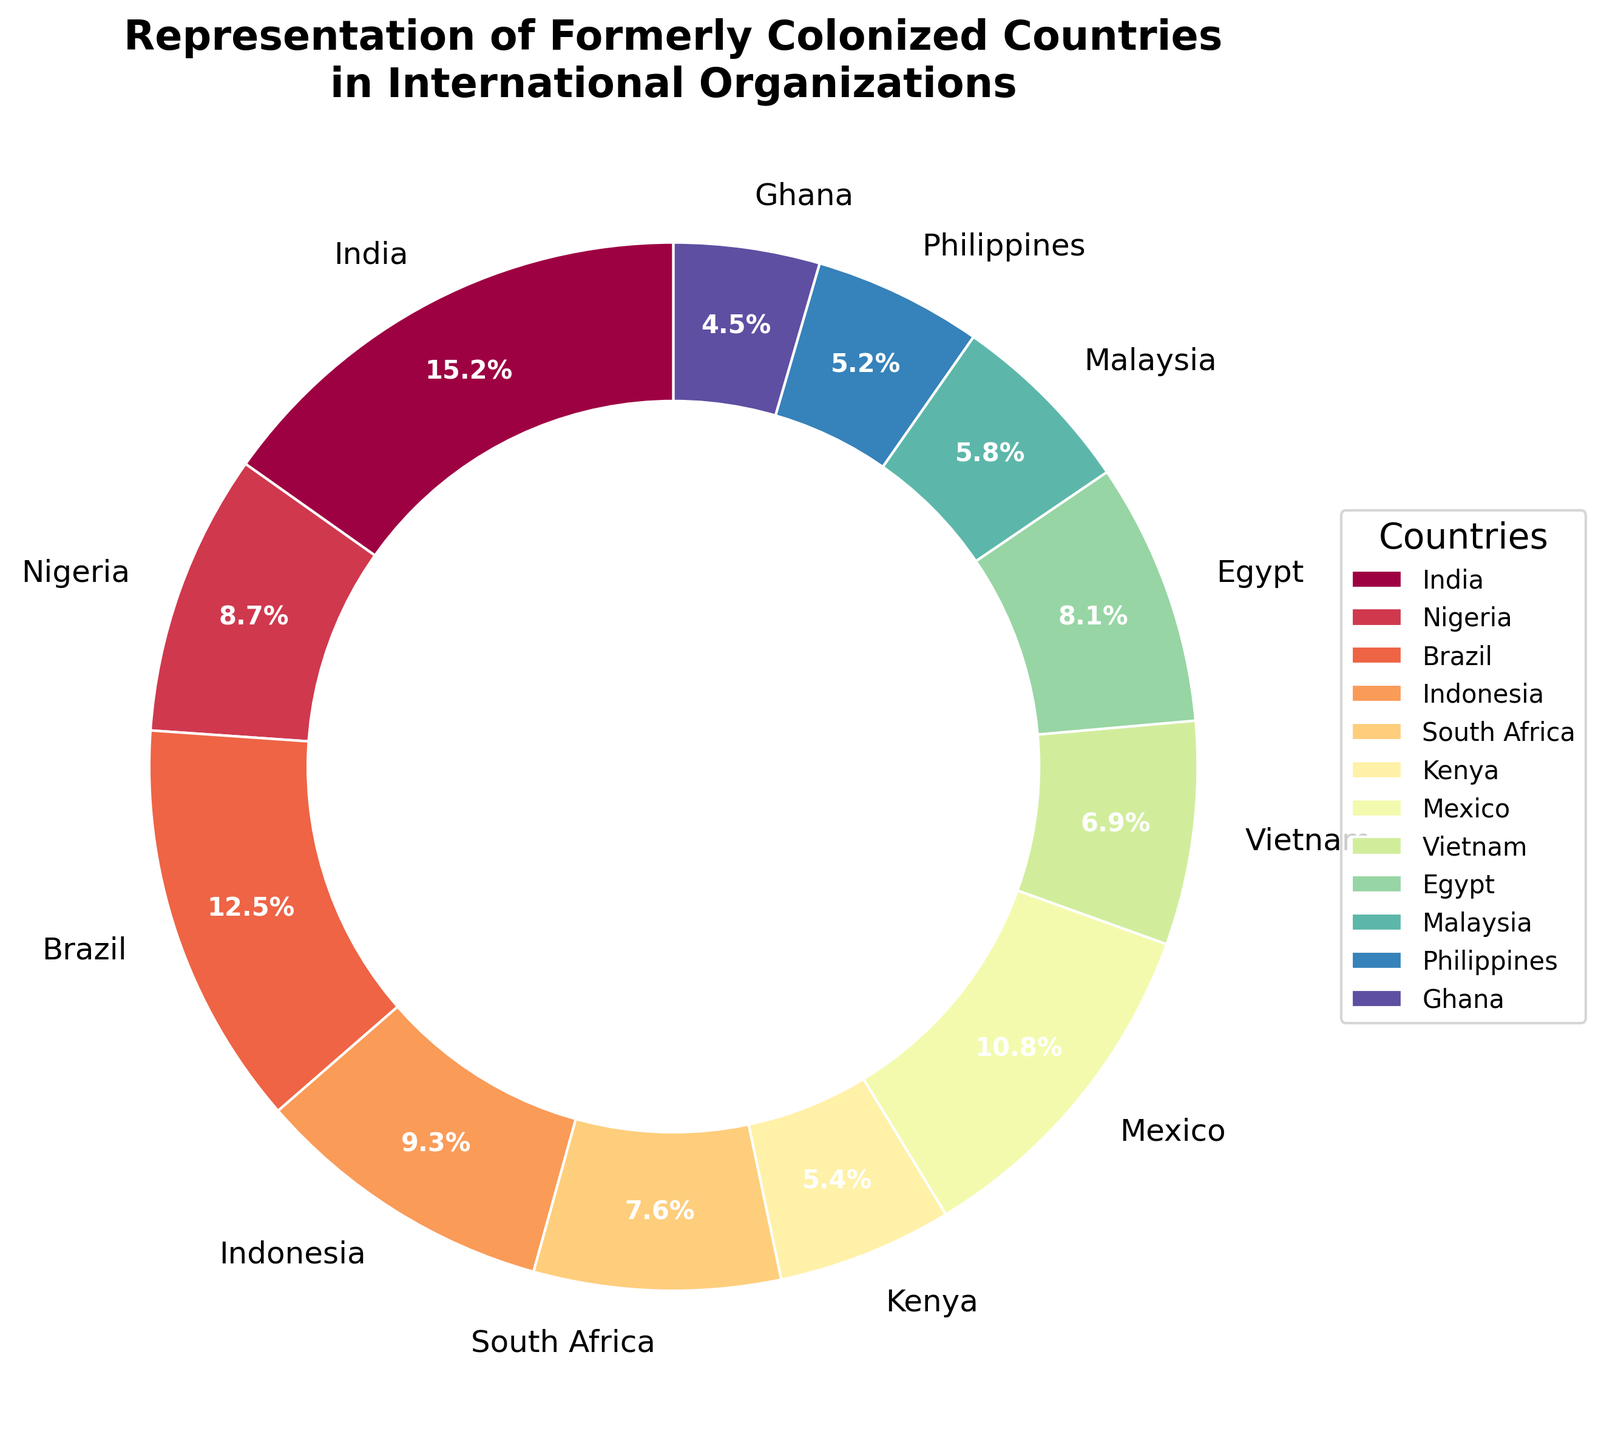What is the percentage representation of Indonesia? By looking at the chart, we can identify that Indonesia has a representation of 9.3%.
Answer: 9.3% Which country has the highest representation in international organizations? India has the highest representation as it holds the largest percentage on the pie chart.
Answer: India Combine the percentages of Nigeria, South Africa, and Kenya. What do you get? The percentages for Nigeria, South Africa, and Kenya are 8.7%, 7.6%, and 5.4%, respectively. Summing these values: 8.7 + 7.6 + 5.4 = 21.7%
Answer: 21.7% How does Mexico’s representation compare to that of Egypt? Mexico has a representation of 10.8%, while Egypt has 8.1%. Mexico's percentage is higher.
Answer: Mexico's percentage is higher What is the difference between the percentage representation of India and Brazil? India's representation is 15.2%, and Brazil's is 12.5%. The difference is 15.2 - 12.5 = 2.7%.
Answer: 2.7% Which countries have a representation percentage greater than 10%? By looking at the chart, India has 15.2%, Brazil has 12.5%, and Mexico has 10.8%. These three countries have percentages greater than 10%.
Answer: India, Brazil, Mexico Arrange the countries by their representation percentage in descending order. The countries in descending order based on their representation are: India (15.2%), Brazil (12.5%), Mexico (10.8%), Indonesia (9.3%), Nigeria (8.7%), Egypt (8.1%), South Africa (7.6%), Vietnam (6.9%), Malaysia (5.8%), Kenya (5.4%), Philippines (5.2%), Ghana (4.5%)
Answer: India, Brazil, Mexico, Indonesia, Nigeria, Egypt, South Africa, Vietnam, Malaysia, Kenya, Philippines, Ghana What is the sum of the percentages of the countries with the smallest three representations? The smallest three representations are Ghana (4.5%), Philippines (5.2%), and Kenya (5.4%). Summing these values: 4.5 + 5.2 + 5.4 = 15.1%
Answer: 15.1% Compare the representation percentages of Vietnam and Malaysia. Which one is larger and by how much? Vietnam has a representation percentage of 6.9%, and Malaysia has 5.8%. The difference is 6.9 - 5.8 = 1.1%. Thus, Vietnam's representation is larger by 1.1%.
Answer: Vietnam, 1.1% Which country holds the median representation, and what is its percentage? To find the median representation, we list the countries by percentage: Ghana (4.5%), Philippines (5.2%), Kenya (5.4%), Malaysia (5.8%), Vietnam (6.9%), South Africa (7.6%), Egypt (8.1%), Nigeria (8.7%), Indonesia (9.3%), Mexico (10.8%), Brazil (12.5%), India (15.2%). The median country is South Africa, with a percentage of 7.6%.
Answer: South Africa, 7.6% 